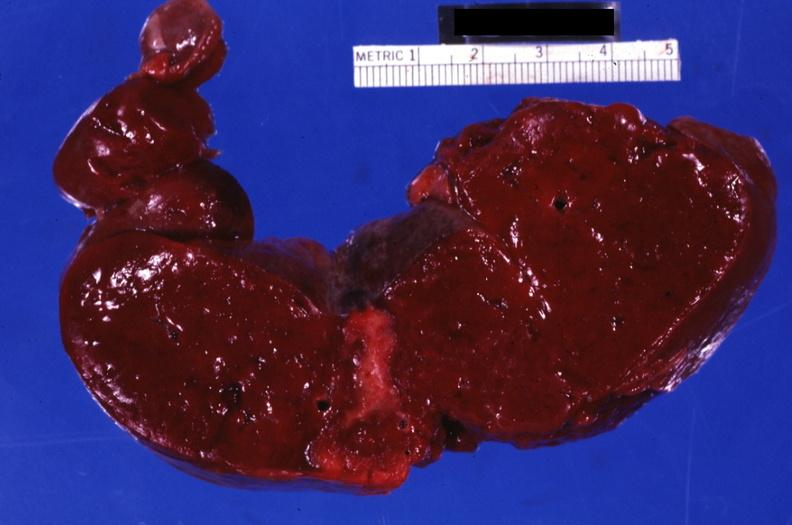what does this image show?
Answer the question using a single word or phrase. Section through spleen with large well shown healing infarct 